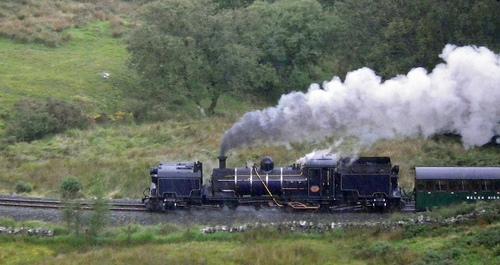How many trains are there?
Give a very brief answer. 1. 